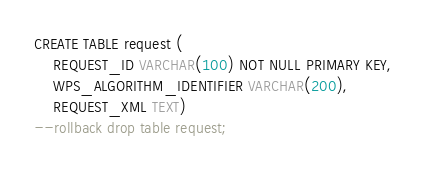<code> <loc_0><loc_0><loc_500><loc_500><_SQL_>CREATE TABLE request (
	REQUEST_ID VARCHAR(100) NOT NULL PRIMARY KEY,
	WPS_ALGORITHM_IDENTIFIER VARCHAR(200),
	REQUEST_XML TEXT)
--rollback drop table request;</code> 